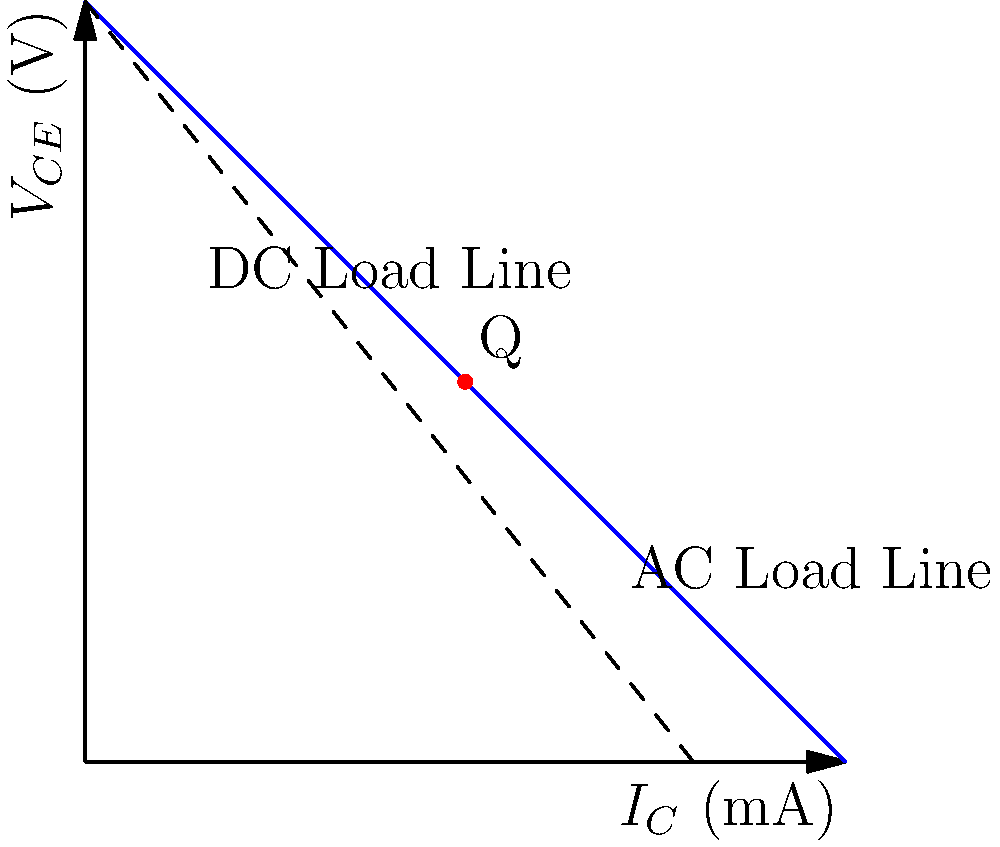Given the load line analysis graph for a common-emitter amplifier, determine the Q-point (quiescent point) coordinates $(I_C, V_{CE})$ of the amplifier. The load line intersects the x-axis at 10 mA and the y-axis at 10 V. The Q-point is located at the midpoint of the AC load line. To determine the Q-point coordinates, we need to follow these steps:

1. Identify the load line:
   The load line is represented by the blue line on the graph, extending from $(0, 10)$ to $(10, 0)$.

2. Understand the load line equation:
   The load line equation is given by $V_{CE} = V_{CC} - I_C R_C$, where $V_{CC}$ is the supply voltage and $R_C$ is the collector resistance.

3. Identify the AC load line:
   The AC load line is the same as the blue line shown in the graph.

4. Locate the Q-point:
   The Q-point is marked with a red dot on the graph, at the midpoint of the AC load line.

5. Determine the coordinates:
   Since the Q-point is at the midpoint of the load line, we can calculate its coordinates:
   
   $I_C = \frac{10 \text{ mA}}{2} = 5 \text{ mA}$
   $V_{CE} = \frac{10 \text{ V}}{2} = 5 \text{ V}$

Therefore, the Q-point coordinates are $(5 \text{ mA}, 5 \text{ V})$.
Answer: $(5 \text{ mA}, 5 \text{ V})$ 